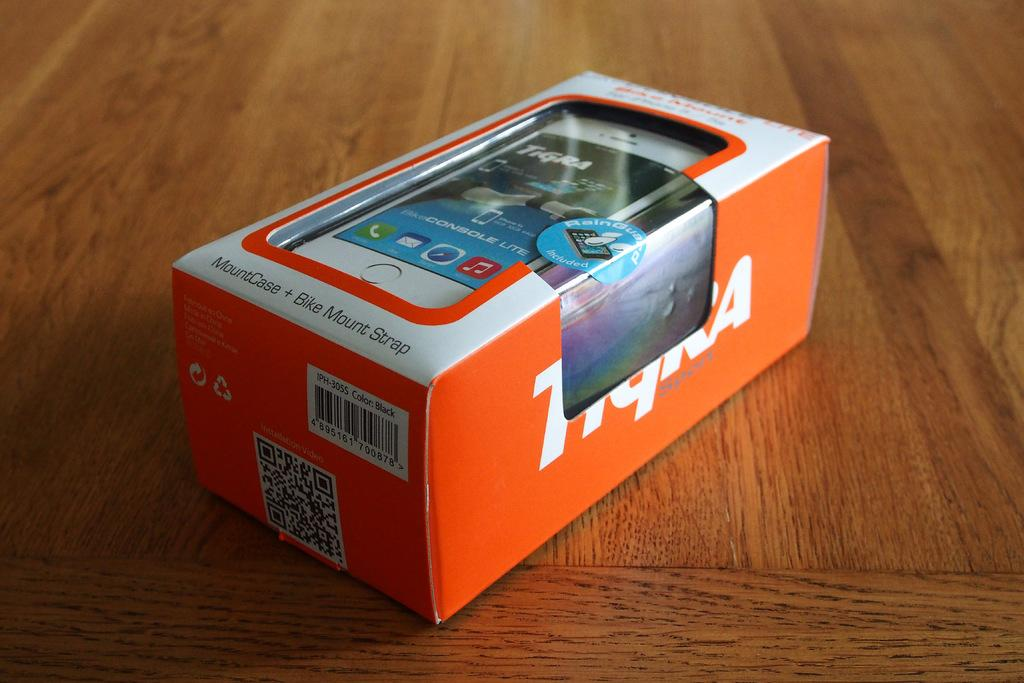Provide a one-sentence caption for the provided image. A box containing a Tigra Sport MountCase + Bike Mount Strap. 